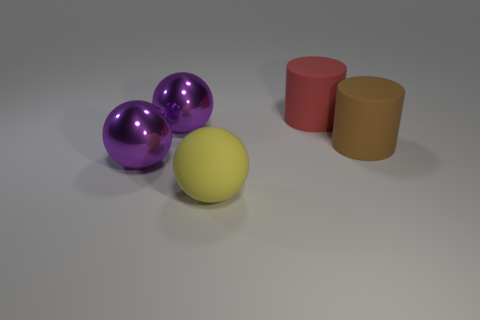Do the brown thing and the big yellow sphere to the left of the red rubber thing have the same material?
Provide a short and direct response. Yes. How many large cylinders have the same material as the big yellow thing?
Provide a short and direct response. 2. What shape is the big purple object that is in front of the brown cylinder?
Your response must be concise. Sphere. Does the big yellow thing that is in front of the big red matte cylinder have the same material as the object that is right of the red thing?
Keep it short and to the point. Yes. Is there another metal object that has the same shape as the yellow object?
Provide a succinct answer. Yes. What number of objects are cylinders that are in front of the red cylinder or brown rubber cylinders?
Keep it short and to the point. 1. Are there more yellow things that are behind the red cylinder than yellow things in front of the large yellow rubber thing?
Make the answer very short. No. How many matte things are brown cylinders or yellow things?
Your answer should be very brief. 2. Is the number of red cylinders that are in front of the yellow rubber sphere less than the number of big brown matte cylinders that are right of the large red thing?
Your answer should be compact. Yes. What number of things are either big red matte cylinders or large objects that are to the right of the red rubber cylinder?
Your response must be concise. 2. 